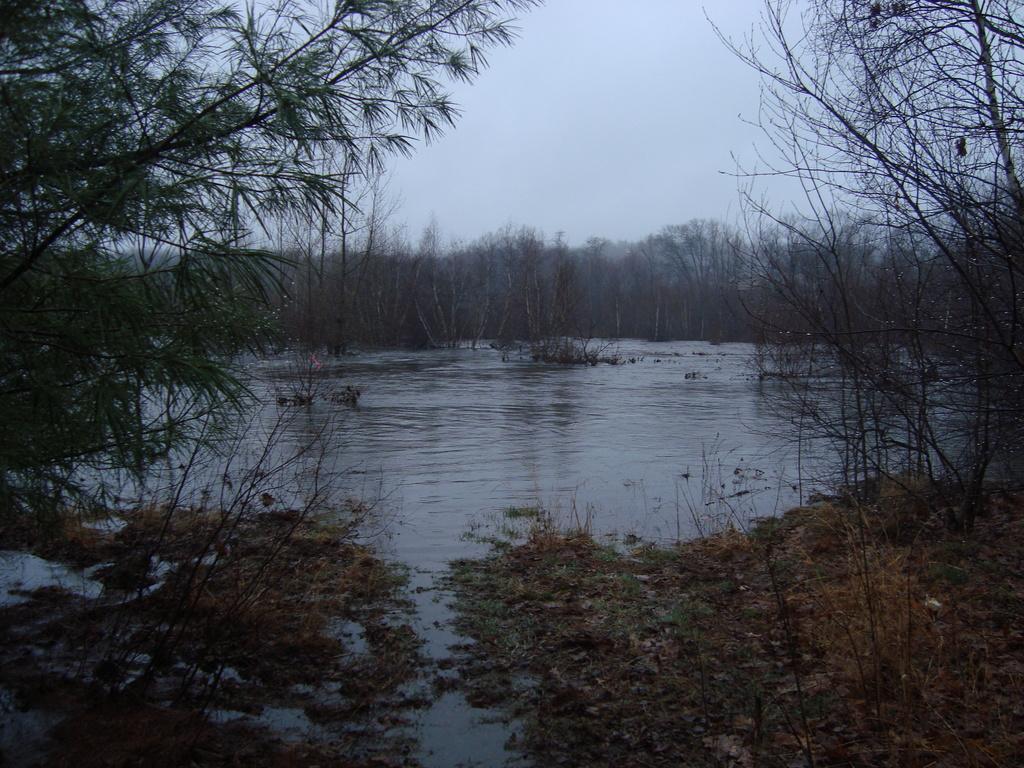Please provide a concise description of this image. We can see water, plants and trees. In the background we can see sky. 